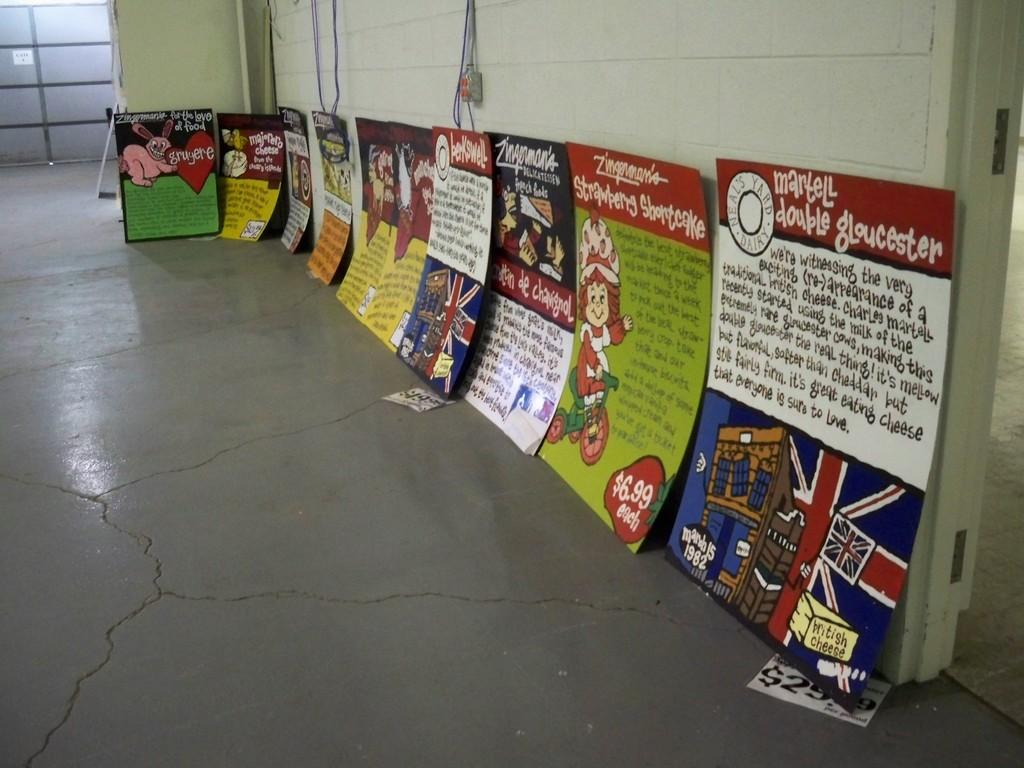<image>
Provide a brief description of the given image. A hallway of signs where the closest one says Martell double gloucester. 